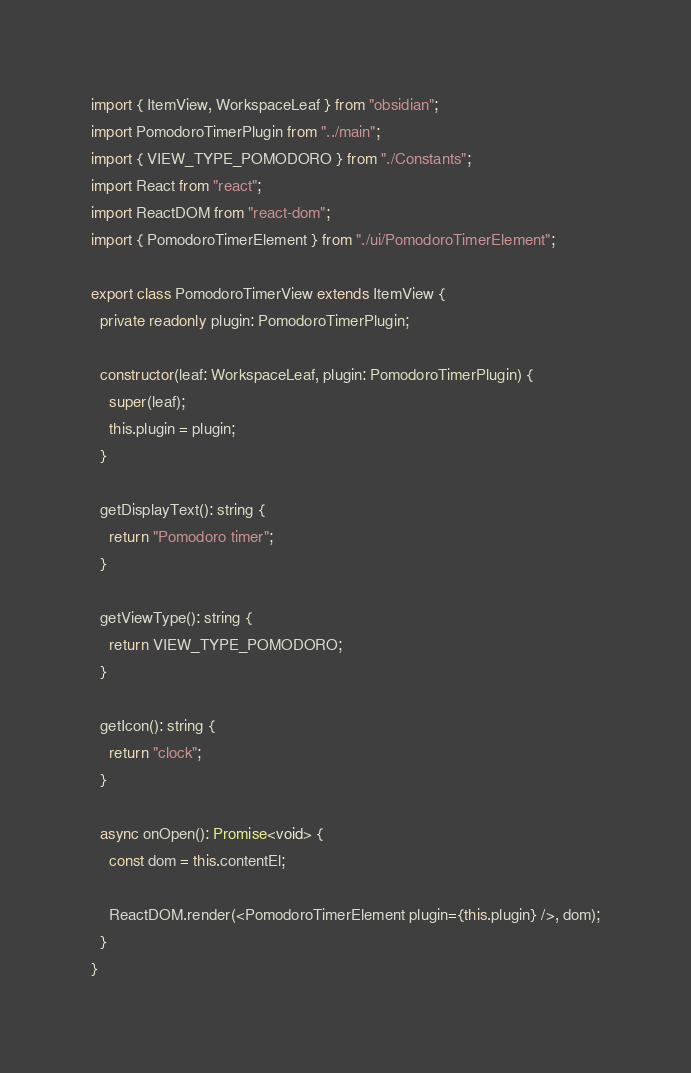Convert code to text. <code><loc_0><loc_0><loc_500><loc_500><_TypeScript_>import { ItemView, WorkspaceLeaf } from "obsidian";
import PomodoroTimerPlugin from "../main";
import { VIEW_TYPE_POMODORO } from "./Constants";
import React from "react";
import ReactDOM from "react-dom";
import { PomodoroTimerElement } from "./ui/PomodoroTimerElement";

export class PomodoroTimerView extends ItemView {
  private readonly plugin: PomodoroTimerPlugin;

  constructor(leaf: WorkspaceLeaf, plugin: PomodoroTimerPlugin) {
    super(leaf);
    this.plugin = plugin;
  }

  getDisplayText(): string {
    return "Pomodoro timer";
  }

  getViewType(): string {
    return VIEW_TYPE_POMODORO;
  }

  getIcon(): string {
    return "clock";
  }

  async onOpen(): Promise<void> {
    const dom = this.contentEl;

    ReactDOM.render(<PomodoroTimerElement plugin={this.plugin} />, dom);
  }
}
</code> 